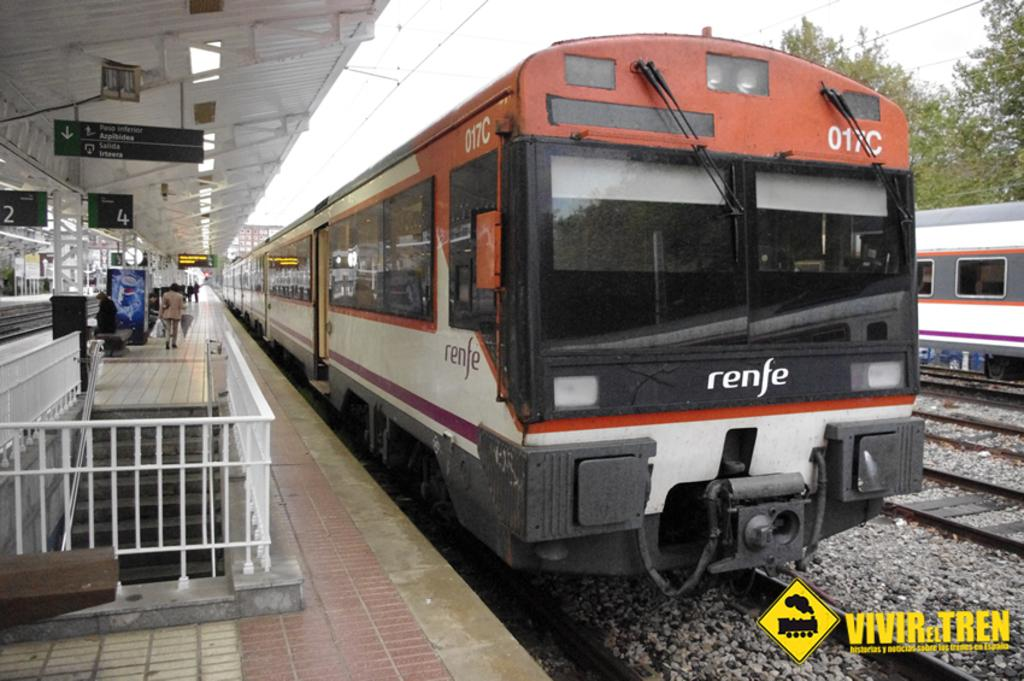<image>
Render a clear and concise summary of the photo. A railway station has a renfe train sitting on the tracks. 